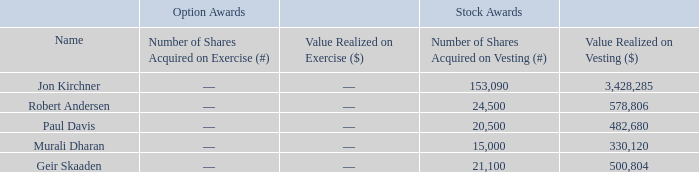Option Exercises and Stock Vested
The table below sets forth information concerning the number of shares acquired on exercise of option awards and vesting of stock awards in 2019 and the value realized upon vesting by such officers.
(1) Amounts realized from the vesting of stock awards are calculated by multiplying the number of shares that vested by the fair market value of a share of our common stock on the vesting date.
What does the table show us? The number of shares acquired on exercise of option awards and vesting of stock awards in 2019 and the value realized upon vesting by such officers. How many shares did Jon Kirchner acquire in 2019 through exercise and vesting, respectively? 0, 153,090. Which officers are shown in the table? Jon kirchner, robert andersen, paul davis, murali dharan, geir skaaden. What is the average number of shares that the officers acquired on vesting? (153,090+24,500+20,500+15,000+21,100)/5 
Answer: 46838. What is the average value per share that Robert Andersen acquired on vesting? 578,806/24,500 
Answer: 23.62. Who acquired the highest amount of shares on vesting? 153,090 is the highest
Answer: jon kirchner. 